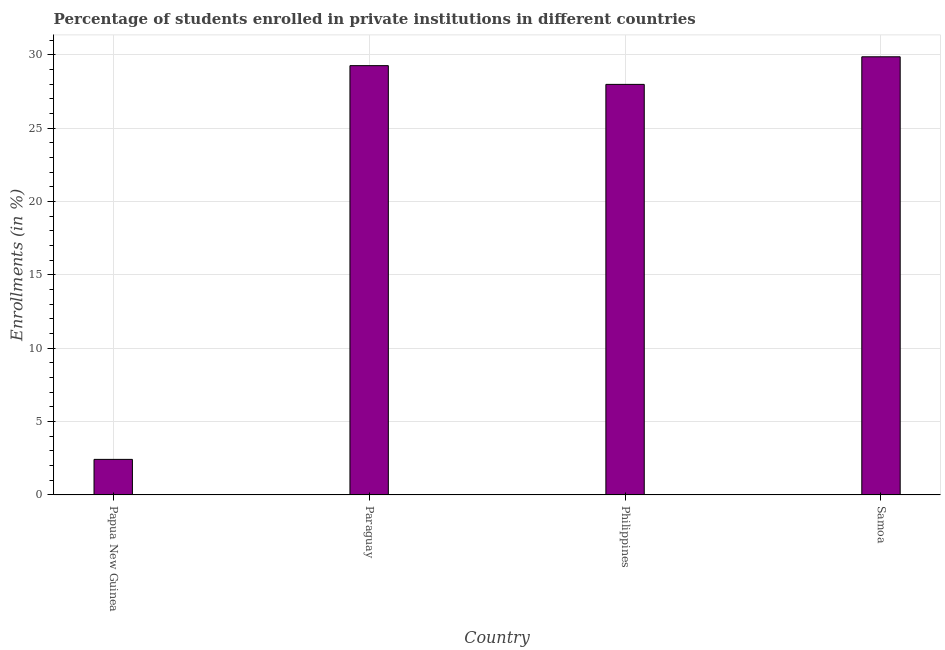Does the graph contain any zero values?
Offer a very short reply. No. What is the title of the graph?
Ensure brevity in your answer.  Percentage of students enrolled in private institutions in different countries. What is the label or title of the Y-axis?
Your answer should be compact. Enrollments (in %). What is the enrollments in private institutions in Papua New Guinea?
Provide a short and direct response. 2.42. Across all countries, what is the maximum enrollments in private institutions?
Give a very brief answer. 29.87. Across all countries, what is the minimum enrollments in private institutions?
Provide a short and direct response. 2.42. In which country was the enrollments in private institutions maximum?
Offer a very short reply. Samoa. In which country was the enrollments in private institutions minimum?
Give a very brief answer. Papua New Guinea. What is the sum of the enrollments in private institutions?
Your response must be concise. 89.54. What is the difference between the enrollments in private institutions in Paraguay and Philippines?
Offer a very short reply. 1.28. What is the average enrollments in private institutions per country?
Keep it short and to the point. 22.39. What is the median enrollments in private institutions?
Offer a terse response. 28.62. In how many countries, is the enrollments in private institutions greater than 4 %?
Offer a terse response. 3. What is the ratio of the enrollments in private institutions in Philippines to that in Samoa?
Your answer should be compact. 0.94. Is the enrollments in private institutions in Papua New Guinea less than that in Philippines?
Your answer should be compact. Yes. Is the difference between the enrollments in private institutions in Paraguay and Samoa greater than the difference between any two countries?
Ensure brevity in your answer.  No. What is the difference between the highest and the second highest enrollments in private institutions?
Provide a short and direct response. 0.6. What is the difference between the highest and the lowest enrollments in private institutions?
Keep it short and to the point. 27.44. Are all the bars in the graph horizontal?
Ensure brevity in your answer.  No. What is the difference between two consecutive major ticks on the Y-axis?
Make the answer very short. 5. Are the values on the major ticks of Y-axis written in scientific E-notation?
Your answer should be compact. No. What is the Enrollments (in %) in Papua New Guinea?
Make the answer very short. 2.42. What is the Enrollments (in %) in Paraguay?
Make the answer very short. 29.26. What is the Enrollments (in %) of Philippines?
Keep it short and to the point. 27.99. What is the Enrollments (in %) in Samoa?
Your answer should be very brief. 29.87. What is the difference between the Enrollments (in %) in Papua New Guinea and Paraguay?
Give a very brief answer. -26.84. What is the difference between the Enrollments (in %) in Papua New Guinea and Philippines?
Your answer should be very brief. -25.56. What is the difference between the Enrollments (in %) in Papua New Guinea and Samoa?
Your response must be concise. -27.44. What is the difference between the Enrollments (in %) in Paraguay and Philippines?
Your answer should be very brief. 1.28. What is the difference between the Enrollments (in %) in Paraguay and Samoa?
Offer a terse response. -0.6. What is the difference between the Enrollments (in %) in Philippines and Samoa?
Offer a terse response. -1.88. What is the ratio of the Enrollments (in %) in Papua New Guinea to that in Paraguay?
Provide a short and direct response. 0.08. What is the ratio of the Enrollments (in %) in Papua New Guinea to that in Philippines?
Offer a very short reply. 0.09. What is the ratio of the Enrollments (in %) in Papua New Guinea to that in Samoa?
Offer a terse response. 0.08. What is the ratio of the Enrollments (in %) in Paraguay to that in Philippines?
Ensure brevity in your answer.  1.05. What is the ratio of the Enrollments (in %) in Paraguay to that in Samoa?
Ensure brevity in your answer.  0.98. What is the ratio of the Enrollments (in %) in Philippines to that in Samoa?
Make the answer very short. 0.94. 